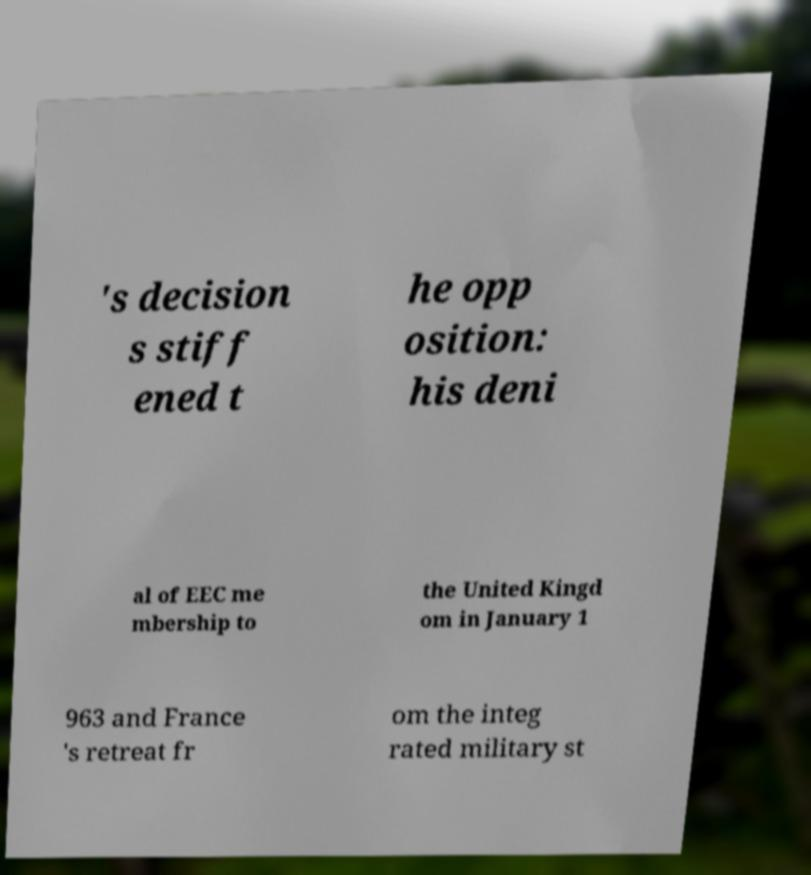I need the written content from this picture converted into text. Can you do that? 's decision s stiff ened t he opp osition: his deni al of EEC me mbership to the United Kingd om in January 1 963 and France 's retreat fr om the integ rated military st 